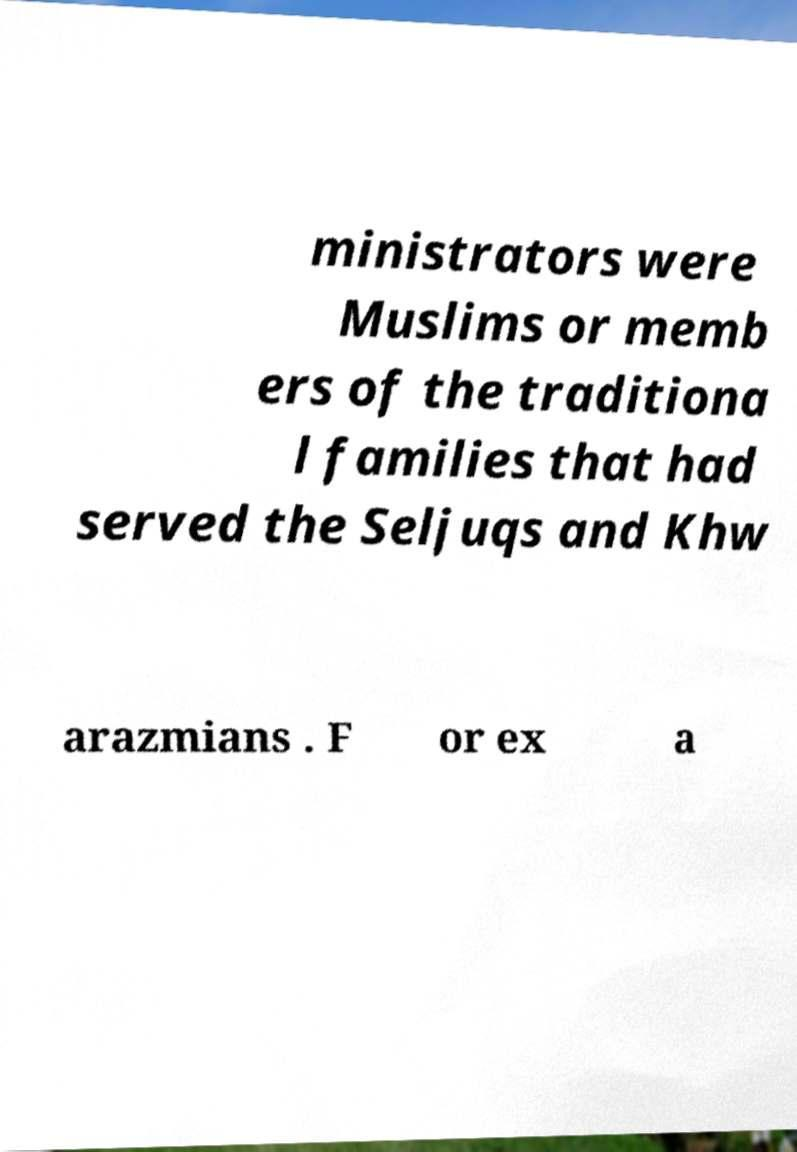Can you accurately transcribe the text from the provided image for me? ministrators were Muslims or memb ers of the traditiona l families that had served the Seljuqs and Khw arazmians . F or ex a 